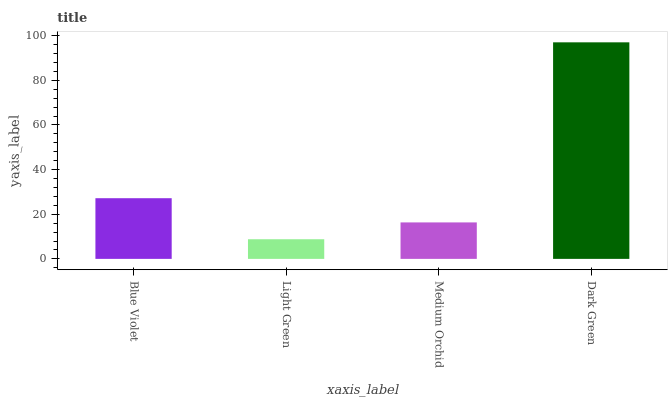Is Light Green the minimum?
Answer yes or no. Yes. Is Dark Green the maximum?
Answer yes or no. Yes. Is Medium Orchid the minimum?
Answer yes or no. No. Is Medium Orchid the maximum?
Answer yes or no. No. Is Medium Orchid greater than Light Green?
Answer yes or no. Yes. Is Light Green less than Medium Orchid?
Answer yes or no. Yes. Is Light Green greater than Medium Orchid?
Answer yes or no. No. Is Medium Orchid less than Light Green?
Answer yes or no. No. Is Blue Violet the high median?
Answer yes or no. Yes. Is Medium Orchid the low median?
Answer yes or no. Yes. Is Medium Orchid the high median?
Answer yes or no. No. Is Blue Violet the low median?
Answer yes or no. No. 